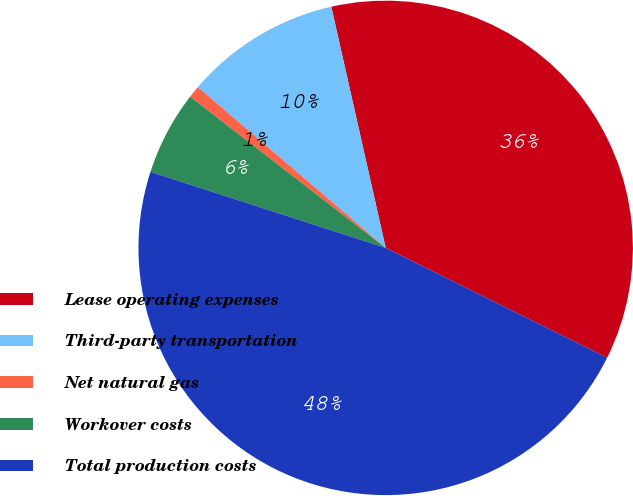Convert chart. <chart><loc_0><loc_0><loc_500><loc_500><pie_chart><fcel>Lease operating expenses<fcel>Third-party transportation<fcel>Net natural gas<fcel>Workover costs<fcel>Total production costs<nl><fcel>35.86%<fcel>10.2%<fcel>0.79%<fcel>5.5%<fcel>47.65%<nl></chart> 